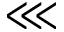<formula> <loc_0><loc_0><loc_500><loc_500>\lll</formula> 